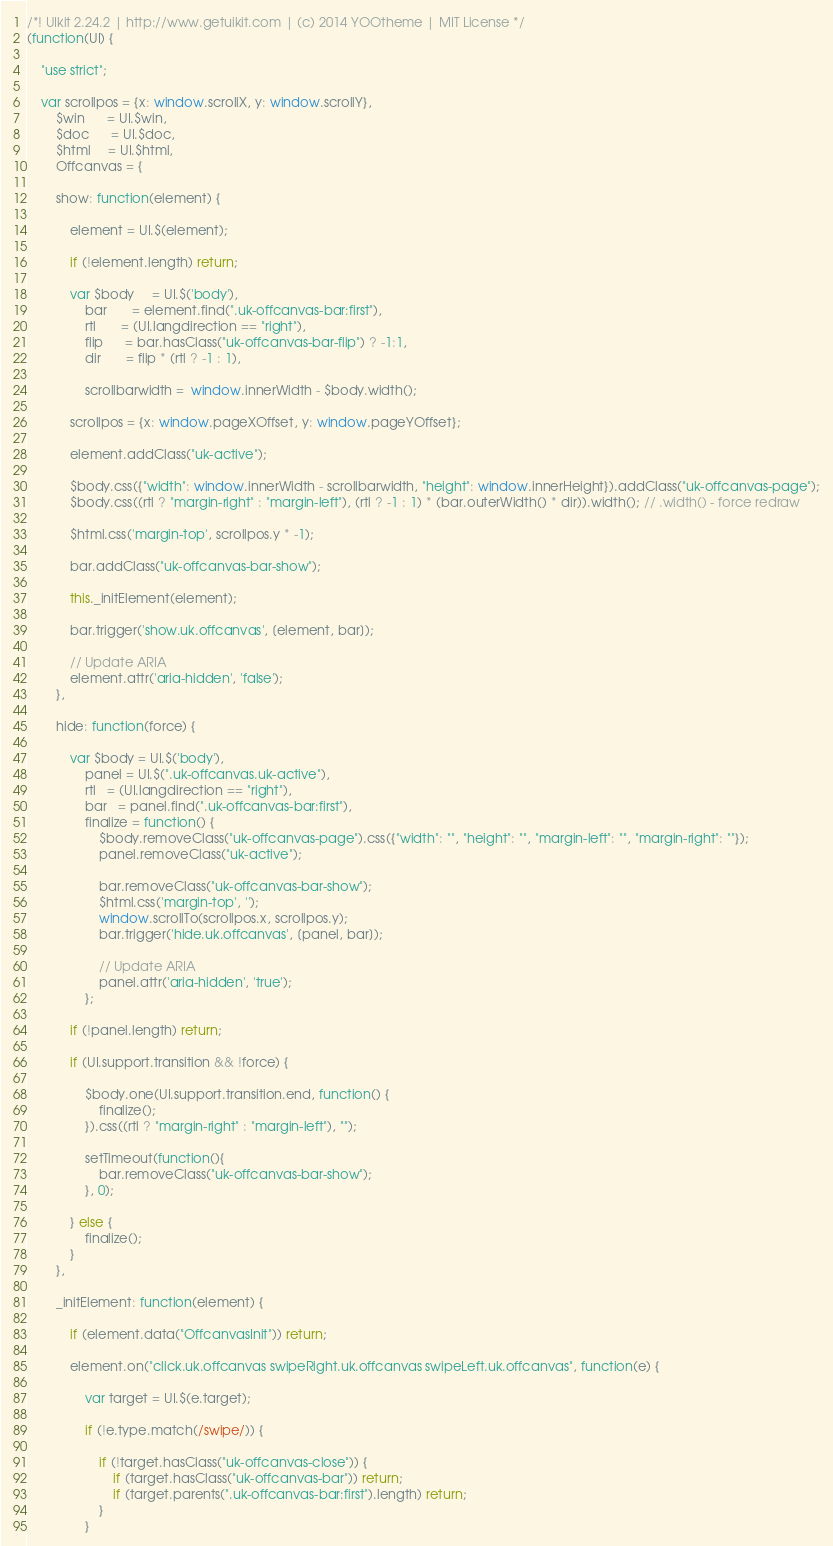<code> <loc_0><loc_0><loc_500><loc_500><_JavaScript_>/*! UIkit 2.24.2 | http://www.getuikit.com | (c) 2014 YOOtheme | MIT License */
(function(UI) {

    "use strict";

    var scrollpos = {x: window.scrollX, y: window.scrollY},
        $win      = UI.$win,
        $doc      = UI.$doc,
        $html     = UI.$html,
        Offcanvas = {

        show: function(element) {

            element = UI.$(element);

            if (!element.length) return;

            var $body     = UI.$('body'),
                bar       = element.find(".uk-offcanvas-bar:first"),
                rtl       = (UI.langdirection == "right"),
                flip      = bar.hasClass("uk-offcanvas-bar-flip") ? -1:1,
                dir       = flip * (rtl ? -1 : 1),

                scrollbarwidth =  window.innerWidth - $body.width();

            scrollpos = {x: window.pageXOffset, y: window.pageYOffset};

            element.addClass("uk-active");

            $body.css({"width": window.innerWidth - scrollbarwidth, "height": window.innerHeight}).addClass("uk-offcanvas-page");
            $body.css((rtl ? "margin-right" : "margin-left"), (rtl ? -1 : 1) * (bar.outerWidth() * dir)).width(); // .width() - force redraw

            $html.css('margin-top', scrollpos.y * -1);

            bar.addClass("uk-offcanvas-bar-show");

            this._initElement(element);

            bar.trigger('show.uk.offcanvas', [element, bar]);

            // Update ARIA
            element.attr('aria-hidden', 'false');
        },

        hide: function(force) {

            var $body = UI.$('body'),
                panel = UI.$(".uk-offcanvas.uk-active"),
                rtl   = (UI.langdirection == "right"),
                bar   = panel.find(".uk-offcanvas-bar:first"),
                finalize = function() {
                    $body.removeClass("uk-offcanvas-page").css({"width": "", "height": "", "margin-left": "", "margin-right": ""});
                    panel.removeClass("uk-active");

                    bar.removeClass("uk-offcanvas-bar-show");
                    $html.css('margin-top', '');
                    window.scrollTo(scrollpos.x, scrollpos.y);
                    bar.trigger('hide.uk.offcanvas', [panel, bar]);

                    // Update ARIA
                    panel.attr('aria-hidden', 'true');
                };

            if (!panel.length) return;

            if (UI.support.transition && !force) {

                $body.one(UI.support.transition.end, function() {
                    finalize();
                }).css((rtl ? "margin-right" : "margin-left"), "");

                setTimeout(function(){
                    bar.removeClass("uk-offcanvas-bar-show");
                }, 0);

            } else {
                finalize();
            }
        },

        _initElement: function(element) {

            if (element.data("OffcanvasInit")) return;

            element.on("click.uk.offcanvas swipeRight.uk.offcanvas swipeLeft.uk.offcanvas", function(e) {

                var target = UI.$(e.target);

                if (!e.type.match(/swipe/)) {

                    if (!target.hasClass("uk-offcanvas-close")) {
                        if (target.hasClass("uk-offcanvas-bar")) return;
                        if (target.parents(".uk-offcanvas-bar:first").length) return;
                    }
                }
</code> 